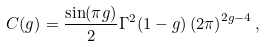Convert formula to latex. <formula><loc_0><loc_0><loc_500><loc_500>C ( g ) = \frac { \sin ( \pi g ) } { 2 } \Gamma ^ { 2 } ( 1 - g ) \left ( 2 \pi \right ) ^ { 2 g - 4 } ,</formula> 